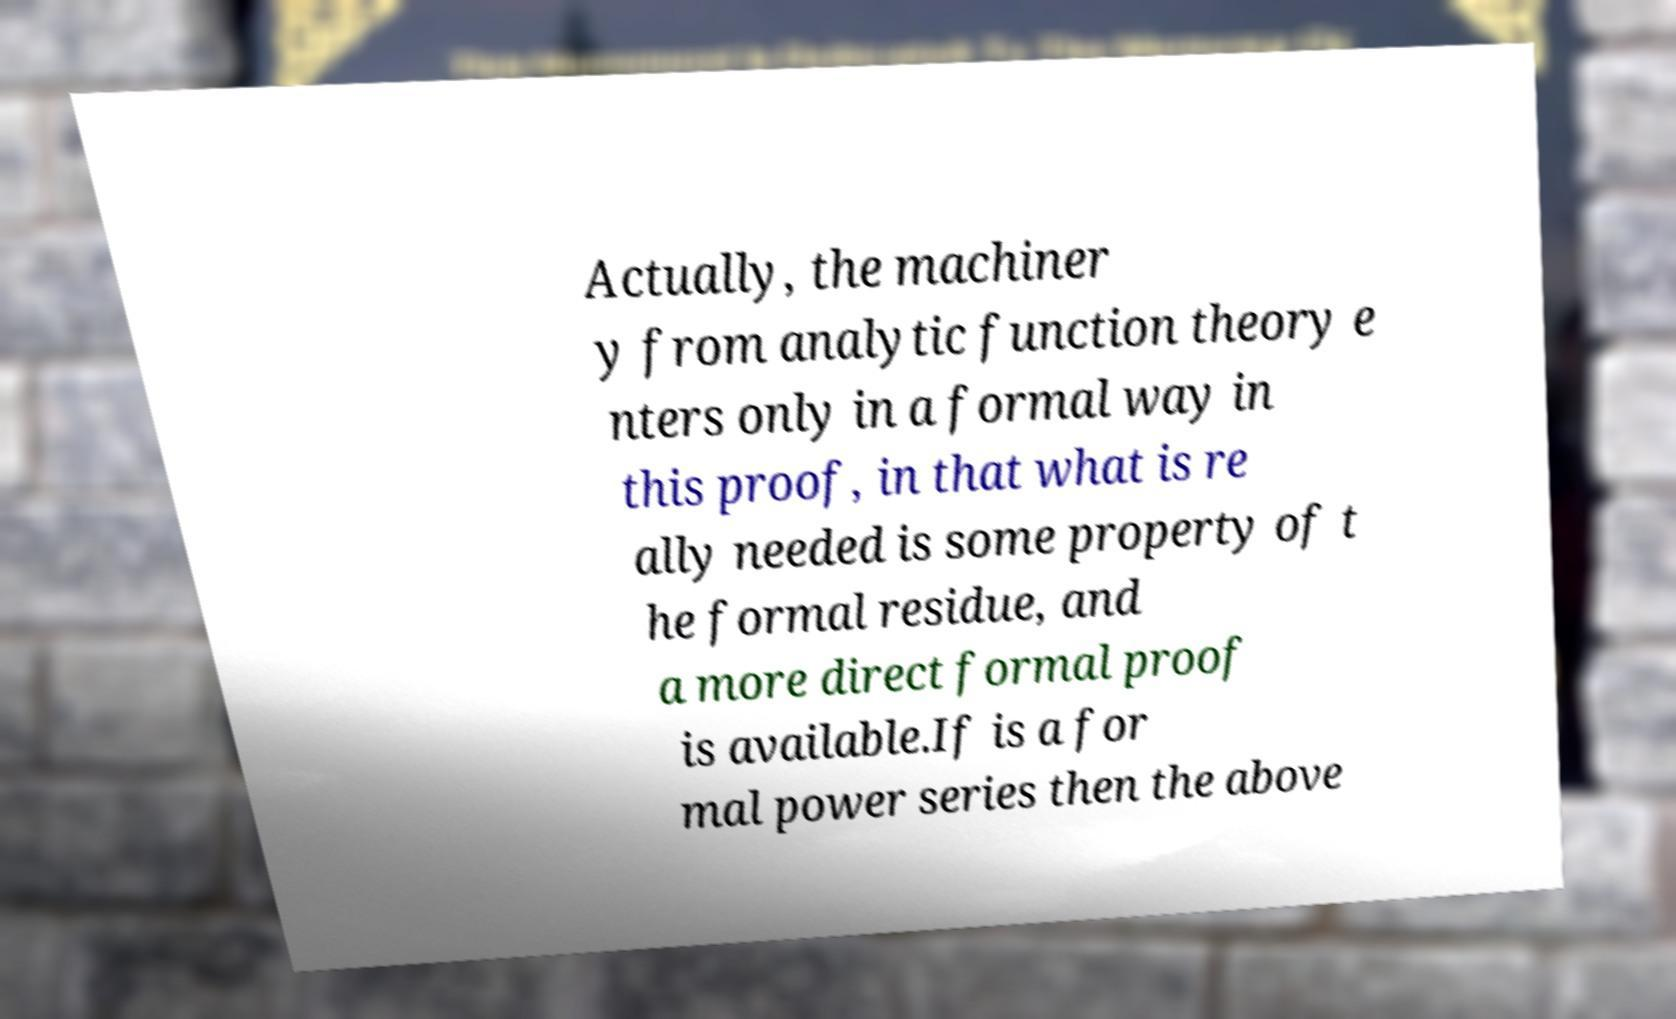Can you read and provide the text displayed in the image?This photo seems to have some interesting text. Can you extract and type it out for me? Actually, the machiner y from analytic function theory e nters only in a formal way in this proof, in that what is re ally needed is some property of t he formal residue, and a more direct formal proof is available.If is a for mal power series then the above 